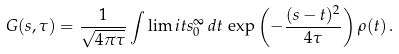<formula> <loc_0><loc_0><loc_500><loc_500>G ( s , \tau ) = \frac { 1 } { \sqrt { 4 \pi \tau } } \int \lim i t s _ { 0 } ^ { \infty } \, d t \, \exp \left ( - \frac { ( s - t ) ^ { 2 } } { 4 \tau } \right ) \rho ( t ) \, .</formula> 